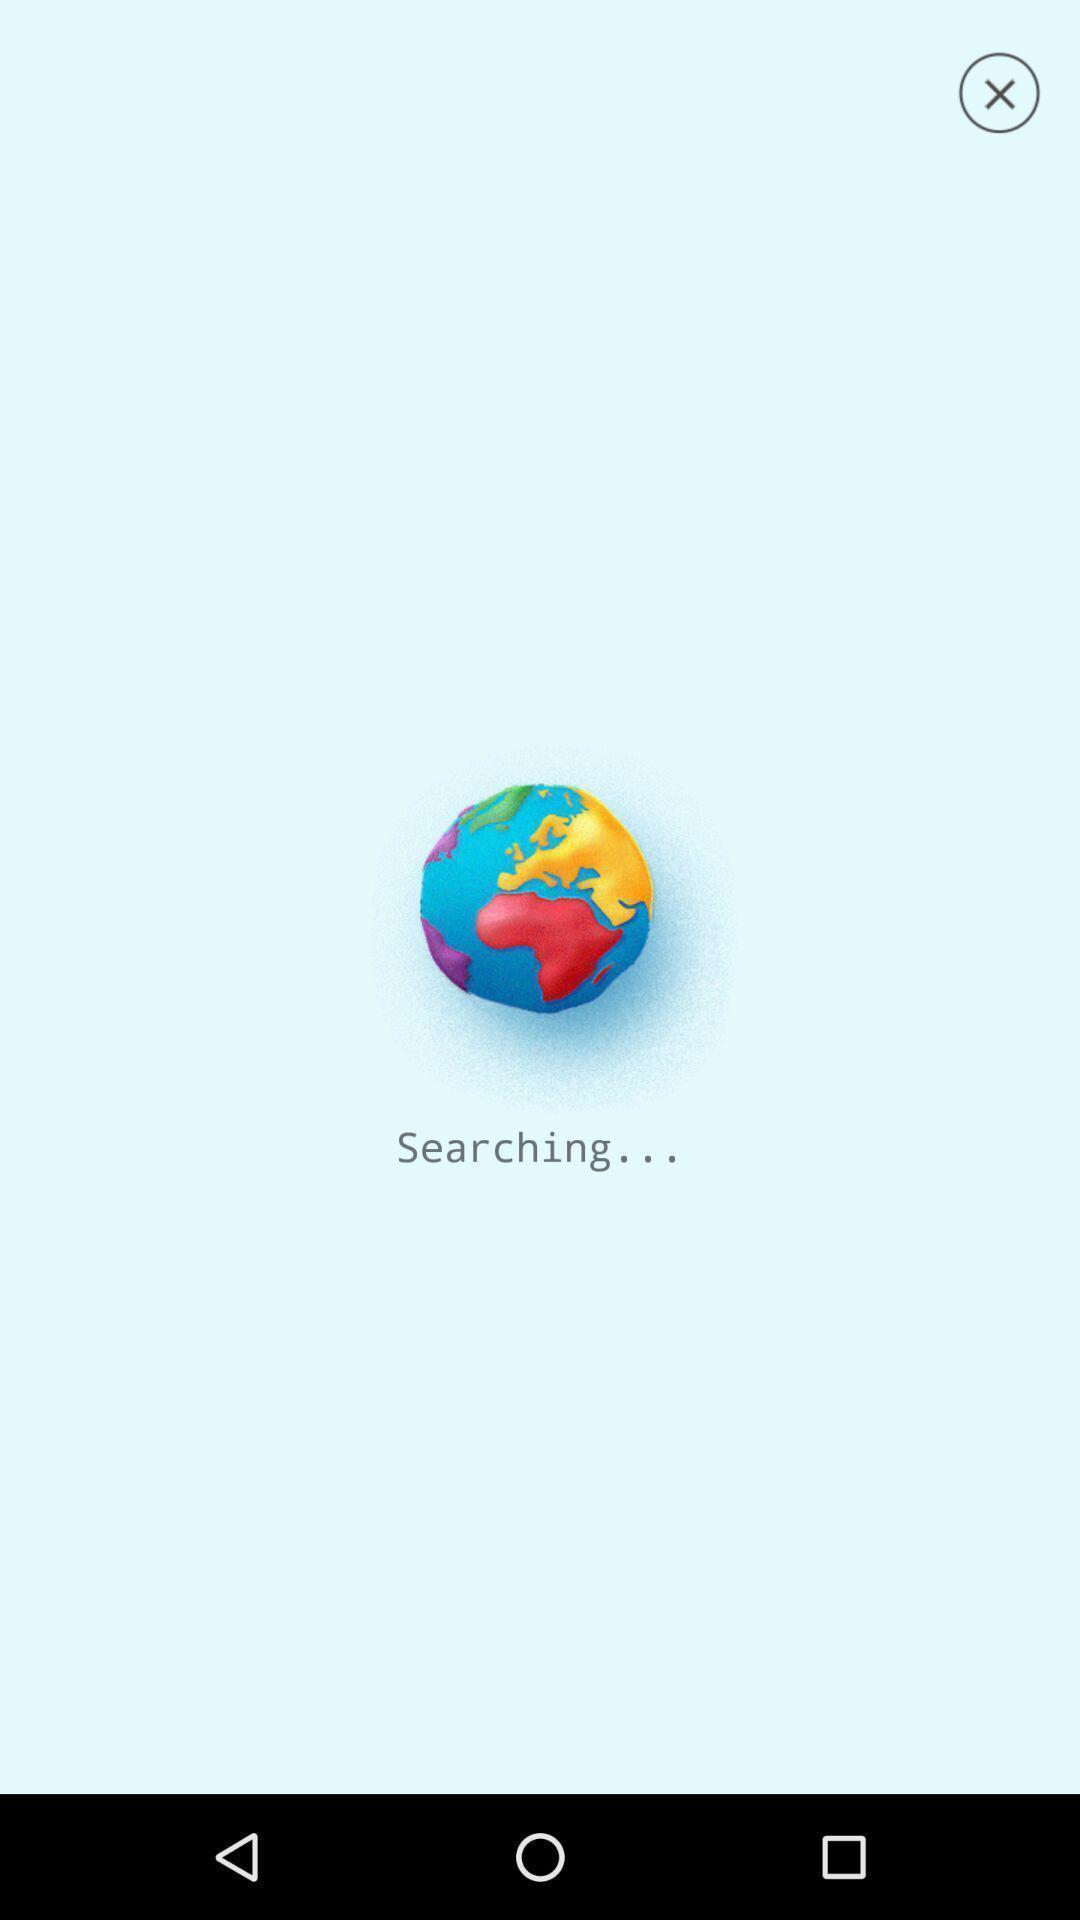Explain the elements present in this screenshot. Welcome page displaying searching. 